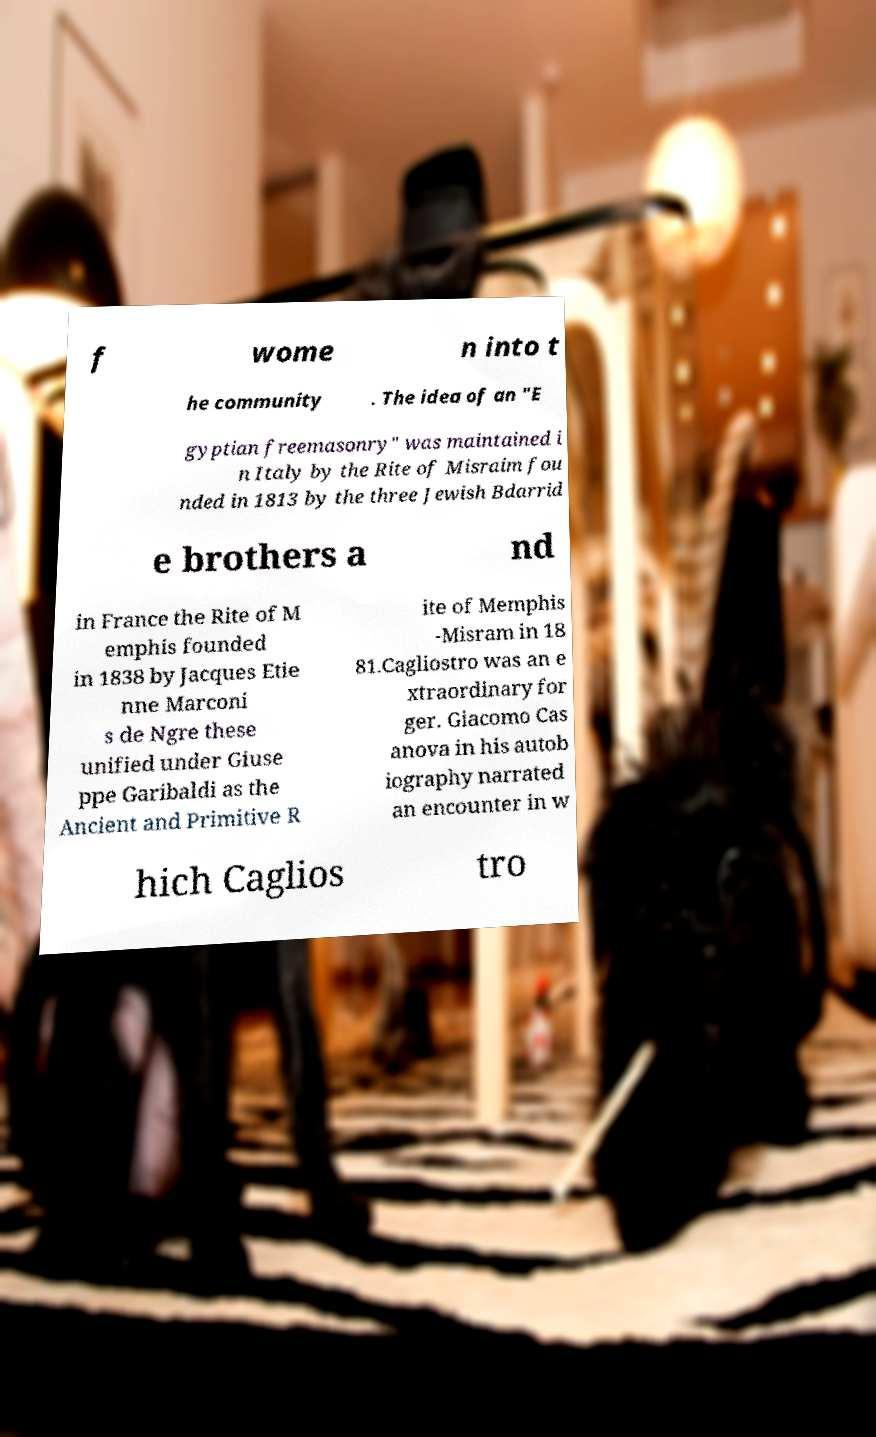Please identify and transcribe the text found in this image. f wome n into t he community . The idea of an "E gyptian freemasonry" was maintained i n Italy by the Rite of Misraim fou nded in 1813 by the three Jewish Bdarrid e brothers a nd in France the Rite of M emphis founded in 1838 by Jacques Etie nne Marconi s de Ngre these unified under Giuse ppe Garibaldi as the Ancient and Primitive R ite of Memphis -Misram in 18 81.Cagliostro was an e xtraordinary for ger. Giacomo Cas anova in his autob iography narrated an encounter in w hich Caglios tro 